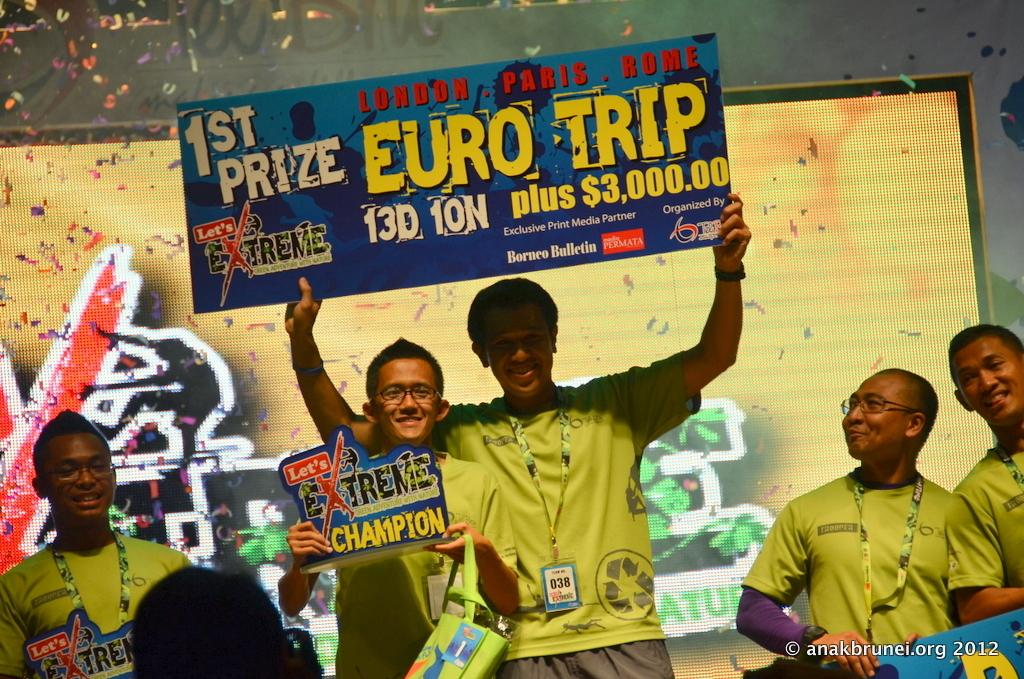What are the men in the image wearing? The men are wearing green t-shirts. What are the men holding in their hands? The men are holding trophies in their hands. What can be seen in the background of the image? There is a screen visible in the background of the image. What type of rabbit can be seen jumping over the fire in the image? There is no rabbit or fire present in the image; it features men holding trophies and a screen in the background. What flavor of eggnog is being served at the event in the image? There is no mention of eggnog or any event in the image. 